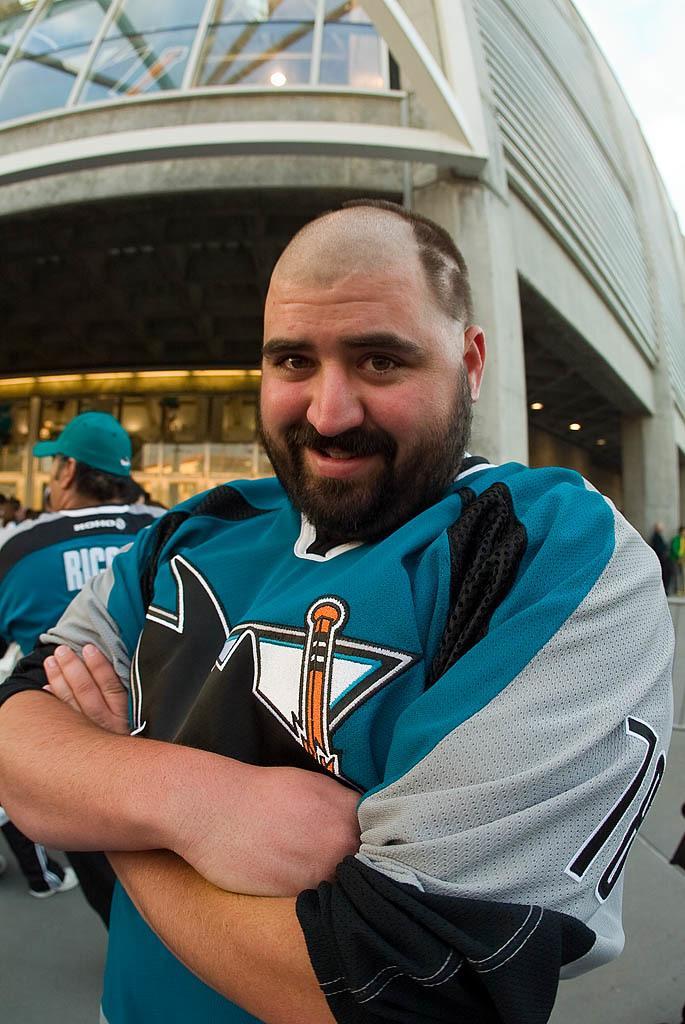Can you describe this image briefly? In this image I can see two persons. In the background I can see a building. 